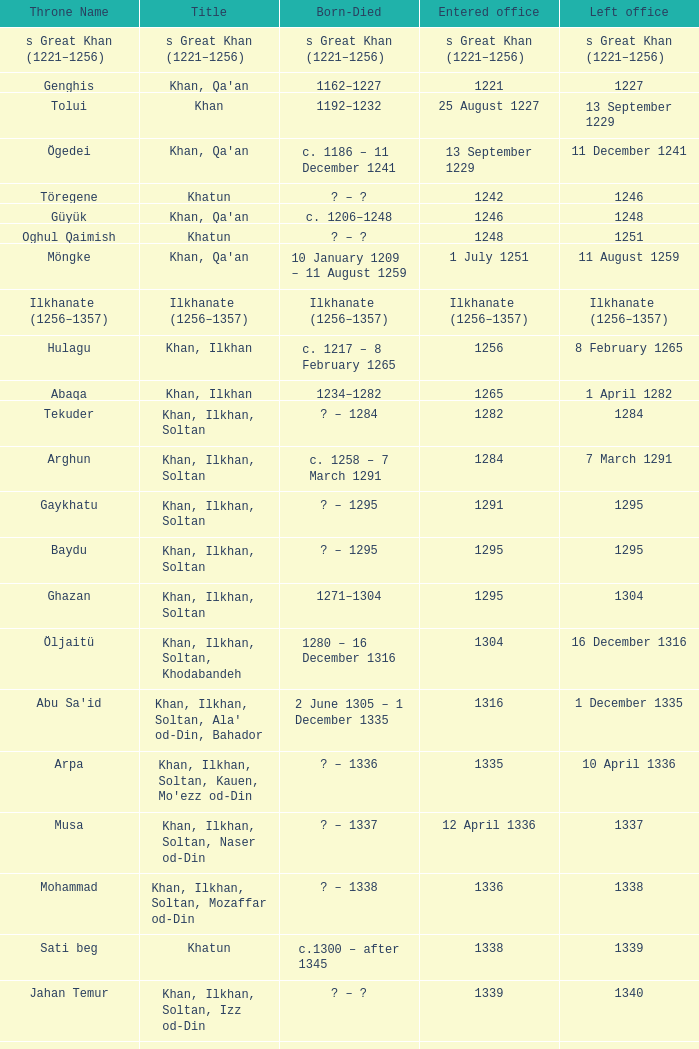What is the birth-death timeline for the one holding office on 13 september 1229? C. 1186 – 11 december 1241. 